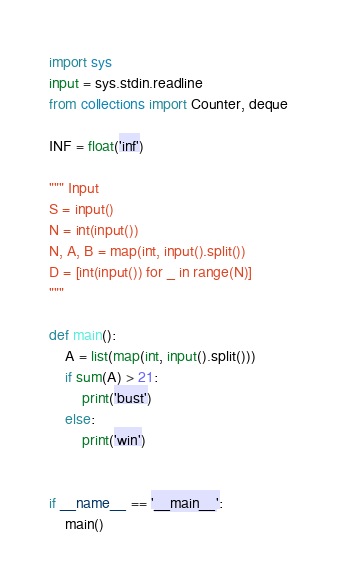<code> <loc_0><loc_0><loc_500><loc_500><_Python_>import sys
input = sys.stdin.readline
from collections import Counter, deque

INF = float('inf')

""" Input
S = input()
N = int(input())
N, A, B = map(int, input().split())
D = [int(input()) for _ in range(N)]
"""

def main():
    A = list(map(int, input().split()))
    if sum(A) > 21:
        print('bust')
    else:
        print('win')


if __name__ == '__main__':
    main()
</code> 